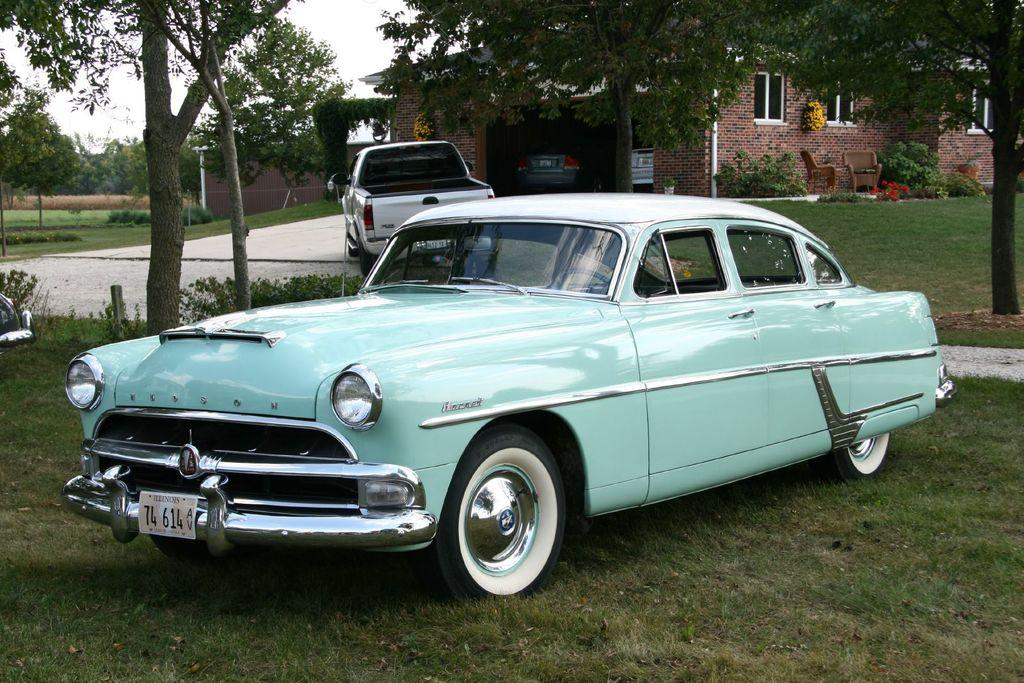What is the main subject of the image? There is a car in the image. What is located behind the car? There is a house behind the car. How many cars can be seen in the image? There are additional cars in the image. What type of vegetation is present in the image? There are trees and plants in the image. What type of lunch is being prepared in the car? There is no indication of any lunch being prepared in the car, as the image only shows the car and its surroundings. 